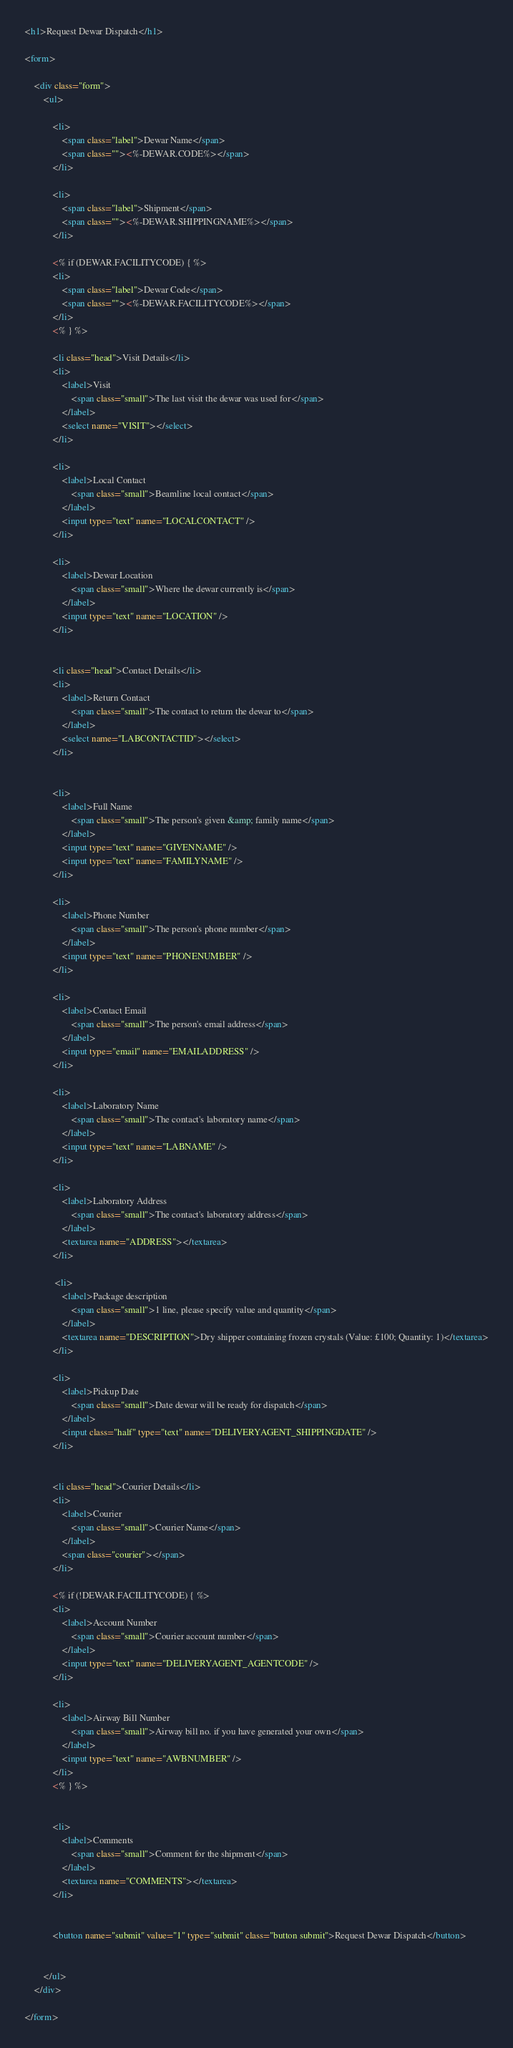<code> <loc_0><loc_0><loc_500><loc_500><_HTML_><h1>Request Dewar Dispatch</h1>

<form>
    
    <div class="form">
        <ul>
            
            <li>
                <span class="label">Dewar Name</span>
                <span class=""><%-DEWAR.CODE%></span>
            </li>

            <li>
                <span class="label">Shipment</span>
                <span class=""><%-DEWAR.SHIPPINGNAME%></span>
            </li>

            <% if (DEWAR.FACILITYCODE) { %>
            <li>
                <span class="label">Dewar Code</span>
                <span class=""><%-DEWAR.FACILITYCODE%></span>
            </li>
            <% } %>
            
            <li class="head">Visit Details</li>
            <li>
                <label>Visit
                    <span class="small">The last visit the dewar was used for</span>
                </label>
                <select name="VISIT"></select>
            </li>
            
            <li>
                <label>Local Contact
                    <span class="small">Beamline local contact</span>
                </label>
                <input type="text" name="LOCALCONTACT" />
            </li>

            <li>
                <label>Dewar Location
                    <span class="small">Where the dewar currently is</span>
                </label>
                <input type="text" name="LOCATION" />
            </li>


            <li class="head">Contact Details</li>
            <li>
                <label>Return Contact
                    <span class="small">The contact to return the dewar to</span>
                </label>
                <select name="LABCONTACTID"></select>
            </li>
            

            <li>
                <label>Full Name
                    <span class="small">The person's given &amp; family name</span>
                </label>
                <input type="text" name="GIVENNAME" />
                <input type="text" name="FAMILYNAME" />
            </li>

            <li>
                <label>Phone Number
                    <span class="small">The person's phone number</span>
                </label>
                <input type="text" name="PHONENUMBER" />
            </li>

            <li>
                <label>Contact Email
                    <span class="small">The person's email address</span>
                </label>
                <input type="email" name="EMAILADDRESS" />
            </li>

            <li>
                <label>Laboratory Name
                    <span class="small">The contact's laboratory name</span>
                </label>
                <input type="text" name="LABNAME" />
            </li>

            <li>
                <label>Laboratory Address
                    <span class="small">The contact's laboratory address</span>
                </label>
                <textarea name="ADDRESS"></textarea>
            </li>

             <li>
                <label>Package description
                    <span class="small">1 line, please specify value and quantity</span>
                </label>
                <textarea name="DESCRIPTION">Dry shipper containing frozen crystals (Value: £100; Quantity: 1)</textarea>
            </li>

            <li>
                <label>Pickup Date
                    <span class="small">Date dewar will be ready for dispatch</span>
                </label>
                <input class="half" type="text" name="DELIVERYAGENT_SHIPPINGDATE" />
            </li>

            
            <li class="head">Courier Details</li>
            <li>
                <label>Courier
                    <span class="small">Courier Name</span>
                </label>
                <span class="courier"></span>
            </li>

            <% if (!DEWAR.FACILITYCODE) { %>
            <li>
                <label>Account Number
                    <span class="small">Courier account number</span>
                </label>
                <input type="text" name="DELIVERYAGENT_AGENTCODE" />
            </li>

            <li>
                <label>Airway Bill Number
                    <span class="small">Airway bill no. if you have generated your own</span>
                </label>
                <input type="text" name="AWBNUMBER" />
            </li>
            <% } %>


            <li>
                <label>Comments
                    <span class="small">Comment for the shipment</span>
                </label>
                <textarea name="COMMENTS"></textarea>
            </li>


            <button name="submit" value="1" type="submit" class="button submit">Request Dewar Dispatch</button>
            
            
        </ul>
    </div>
    
</form>

</code> 